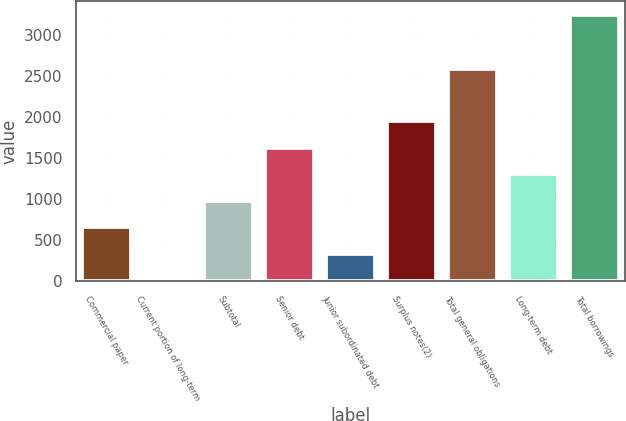Convert chart to OTSL. <chart><loc_0><loc_0><loc_500><loc_500><bar_chart><fcel>Commercial paper<fcel>Current portion of long-term<fcel>Subtotal<fcel>Senior debt<fcel>Junior subordinated debt<fcel>Surplus notes(2)<fcel>Total general obligations<fcel>Long-term debt<fcel>Total borrowings<nl><fcel>652.84<fcel>3.55<fcel>977.49<fcel>1626.78<fcel>328.19<fcel>1951.42<fcel>2591<fcel>1302.13<fcel>3250<nl></chart> 